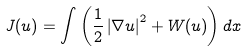Convert formula to latex. <formula><loc_0><loc_0><loc_500><loc_500>J ( u ) = \int \left ( \frac { 1 } { 2 } \left | \nabla u \right | ^ { 2 } + W ( u ) \right ) d x</formula> 